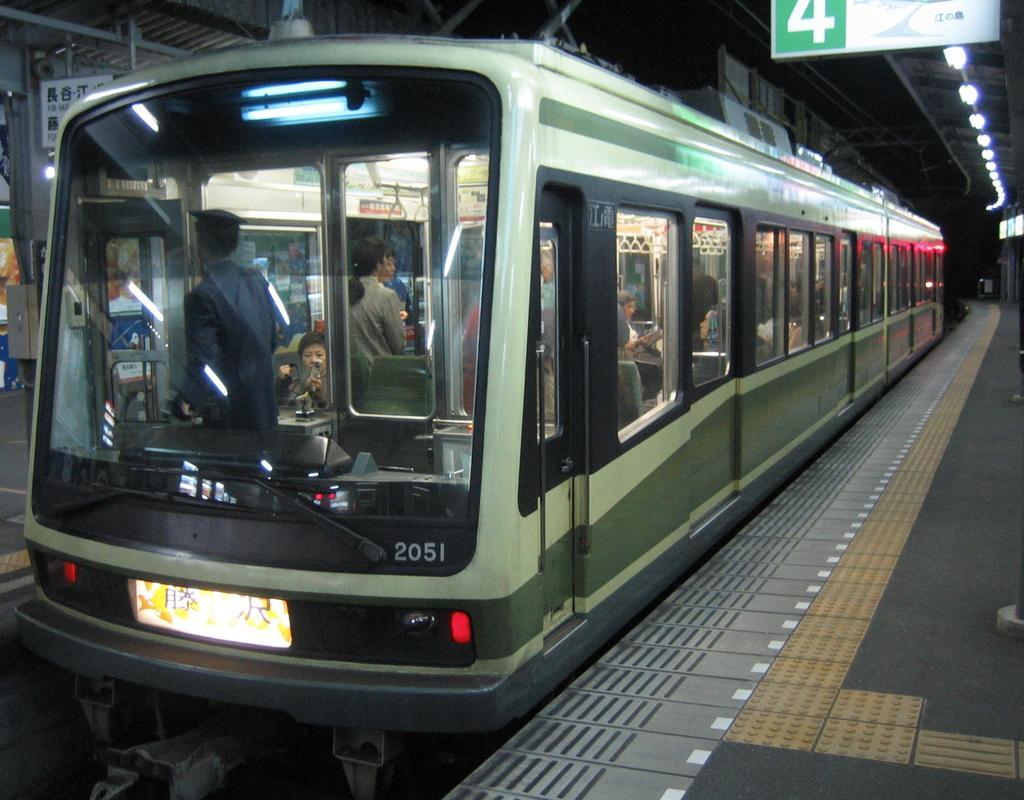In one or two sentences, can you explain what this image depicts? In this picture we can see a group of people sitting on the seats and some people are standing in a train. On the left and right side of the train there are platforms. At the top of the platforms there are boards and lights. At the top of the train there are cables. 